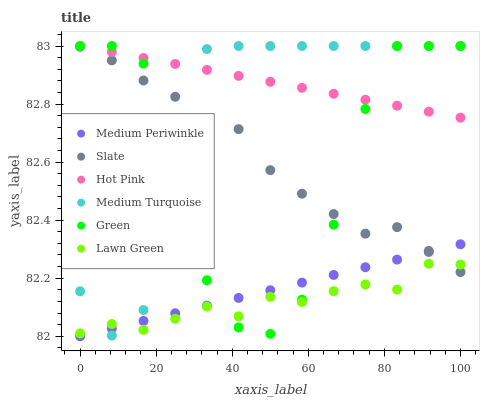Does Lawn Green have the minimum area under the curve?
Answer yes or no. Yes. Does Hot Pink have the maximum area under the curve?
Answer yes or no. Yes. Does Slate have the minimum area under the curve?
Answer yes or no. No. Does Slate have the maximum area under the curve?
Answer yes or no. No. Is Hot Pink the smoothest?
Answer yes or no. Yes. Is Green the roughest?
Answer yes or no. Yes. Is Slate the smoothest?
Answer yes or no. No. Is Slate the roughest?
Answer yes or no. No. Does Medium Periwinkle have the lowest value?
Answer yes or no. Yes. Does Slate have the lowest value?
Answer yes or no. No. Does Medium Turquoise have the highest value?
Answer yes or no. Yes. Does Slate have the highest value?
Answer yes or no. No. Is Medium Periwinkle less than Hot Pink?
Answer yes or no. Yes. Is Hot Pink greater than Lawn Green?
Answer yes or no. Yes. Does Slate intersect Medium Turquoise?
Answer yes or no. Yes. Is Slate less than Medium Turquoise?
Answer yes or no. No. Is Slate greater than Medium Turquoise?
Answer yes or no. No. Does Medium Periwinkle intersect Hot Pink?
Answer yes or no. No. 